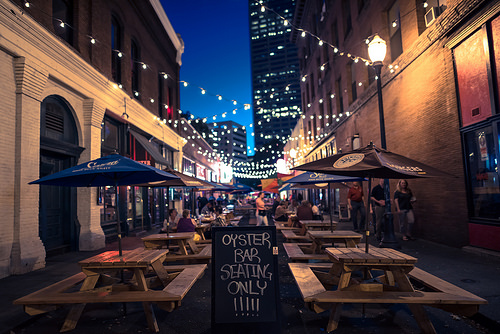<image>
Is the lamp on the wall? No. The lamp is not positioned on the wall. They may be near each other, but the lamp is not supported by or resting on top of the wall. Is the lamppost in front of the umbrella? No. The lamppost is not in front of the umbrella. The spatial positioning shows a different relationship between these objects. 